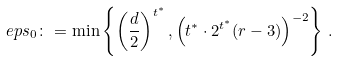<formula> <loc_0><loc_0><loc_500><loc_500>\ e p s _ { 0 } \colon = \min \left \{ \left ( \frac { d } { 2 } \right ) ^ { t ^ { * } } , \left ( t ^ { * } \cdot 2 ^ { t ^ { * } } ( r - 3 ) \right ) ^ { - 2 } \right \} \, .</formula> 